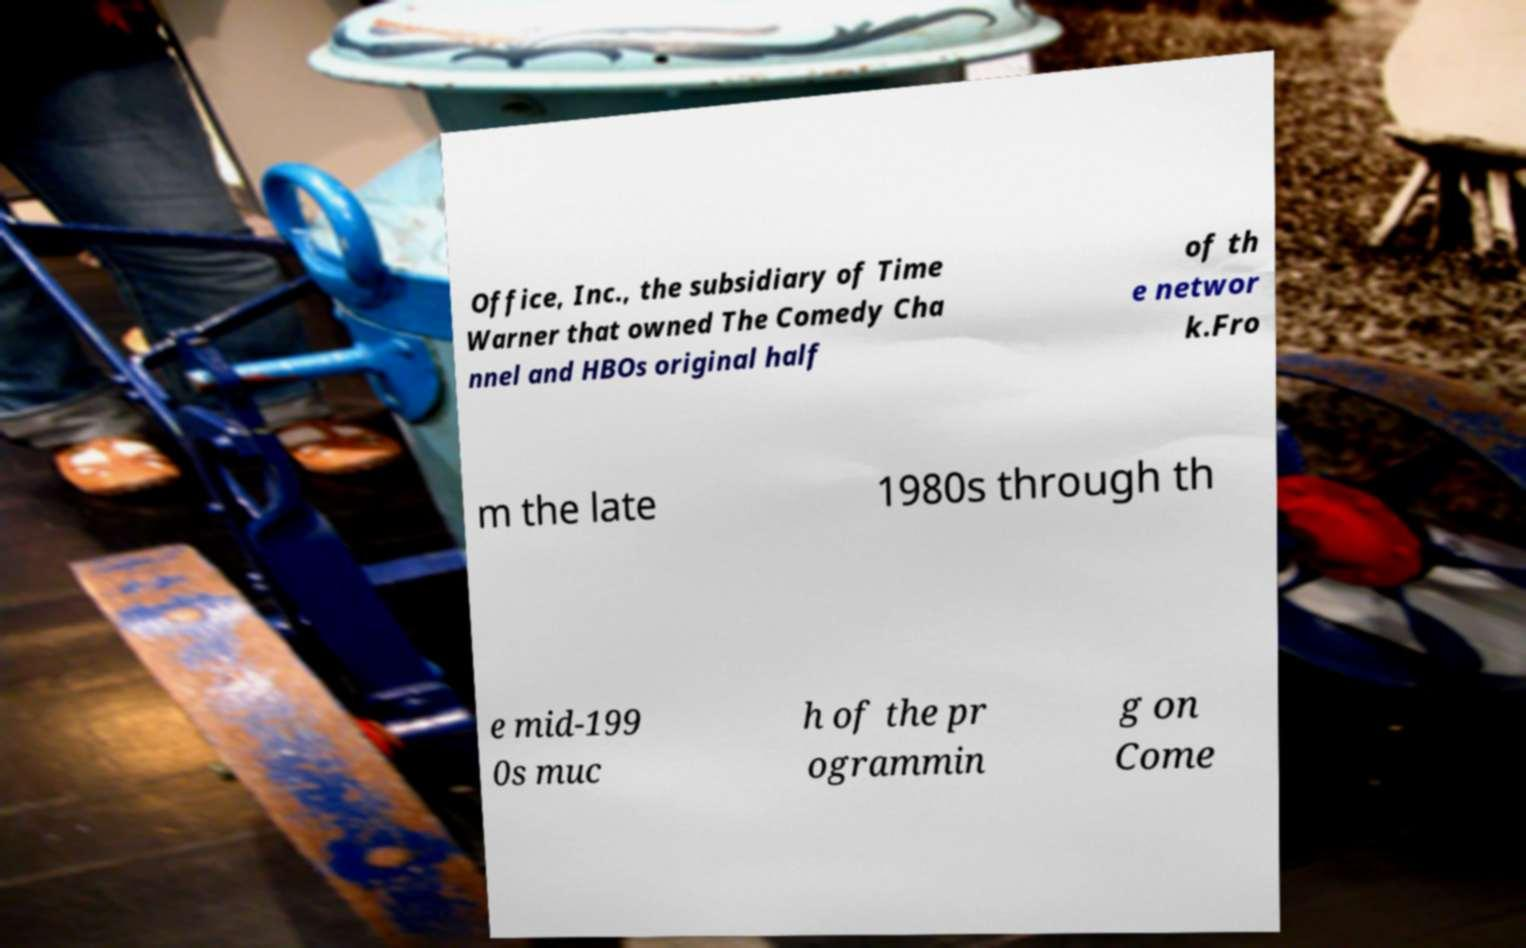I need the written content from this picture converted into text. Can you do that? Office, Inc., the subsidiary of Time Warner that owned The Comedy Cha nnel and HBOs original half of th e networ k.Fro m the late 1980s through th e mid-199 0s muc h of the pr ogrammin g on Come 